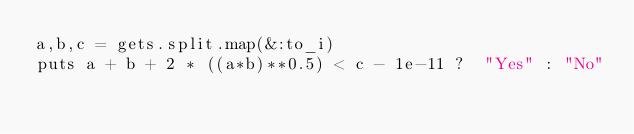<code> <loc_0><loc_0><loc_500><loc_500><_Ruby_>a,b,c = gets.split.map(&:to_i)
puts a + b + 2 * ((a*b)**0.5) < c - 1e-11 ?  "Yes" : "No"</code> 